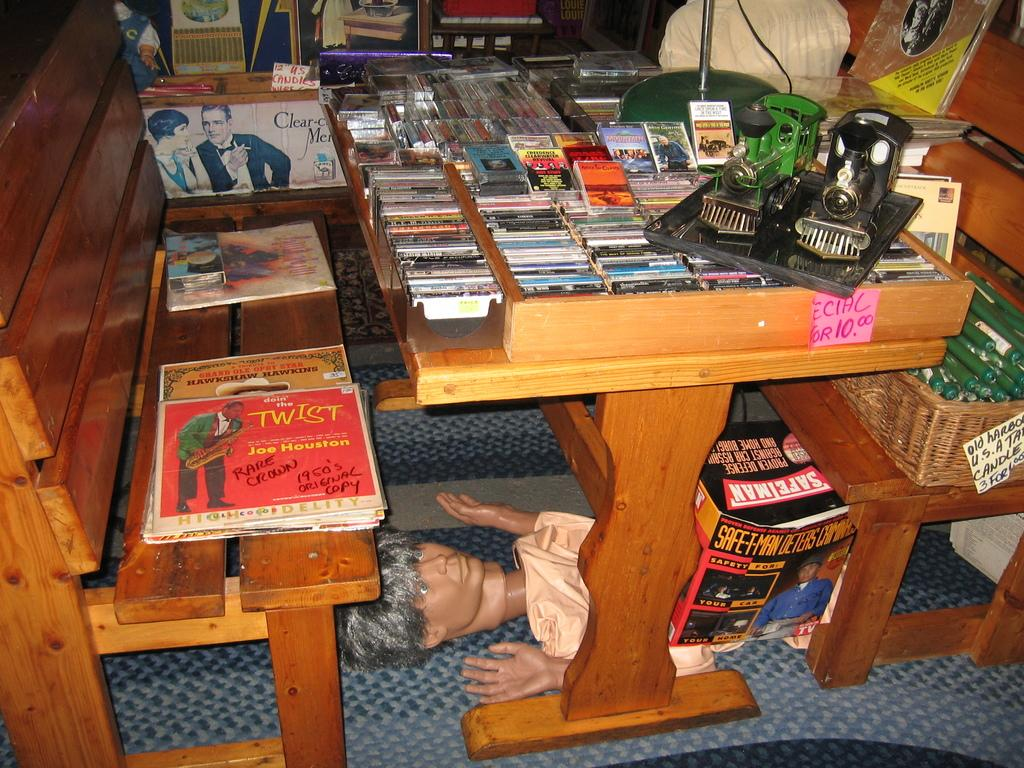What type of furniture is present in the image? There is a table in the image. What is placed on the table in the image? Unfortunately, the provided facts do not specify what is placed on the table. What type of alarm is set on the table in the image? There is no alarm present on the table in the image. Who is the mother of the person standing near the table in the image? There is no person standing near the table in the image, nor is there any information about a mother. 